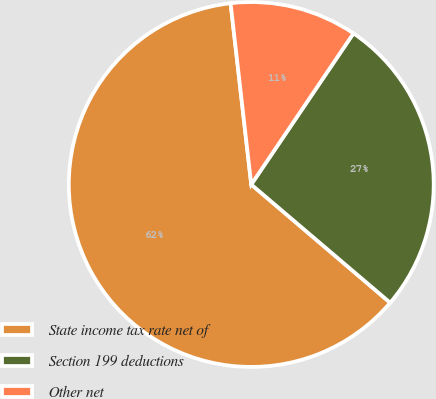Convert chart to OTSL. <chart><loc_0><loc_0><loc_500><loc_500><pie_chart><fcel>State income tax rate net of<fcel>Section 199 deductions<fcel>Other net<nl><fcel>61.97%<fcel>26.76%<fcel>11.27%<nl></chart> 